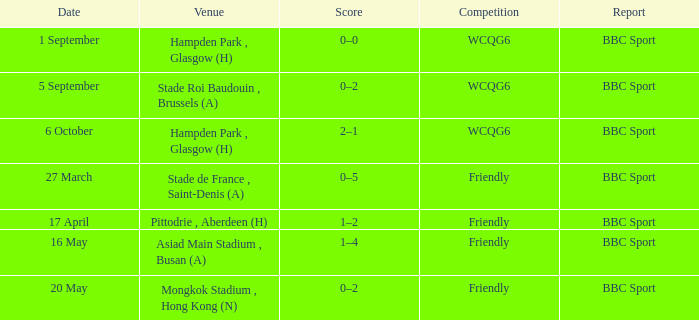Where was the game played on 20 may? Mongkok Stadium , Hong Kong (N). 